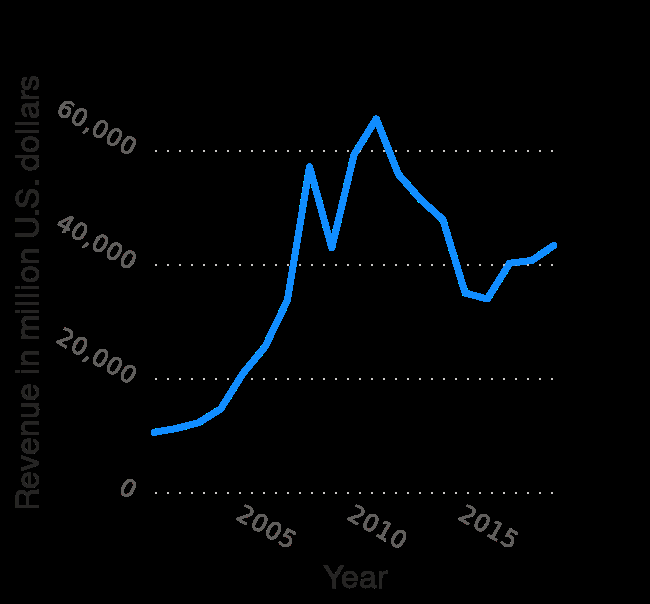<image>
In which year does the x-axis start and end?  The x-axis starts from the year 2005 and ends at the year 2015. What is the range of the y-axis on the line diagram?  The range of the y-axis on the line diagram is from 0 to 60,000 million U.S. dollars. Which year had the highest revenue apart from 2010?  The year with the highest revenue apart from 2010 is not mentioned in the description. 